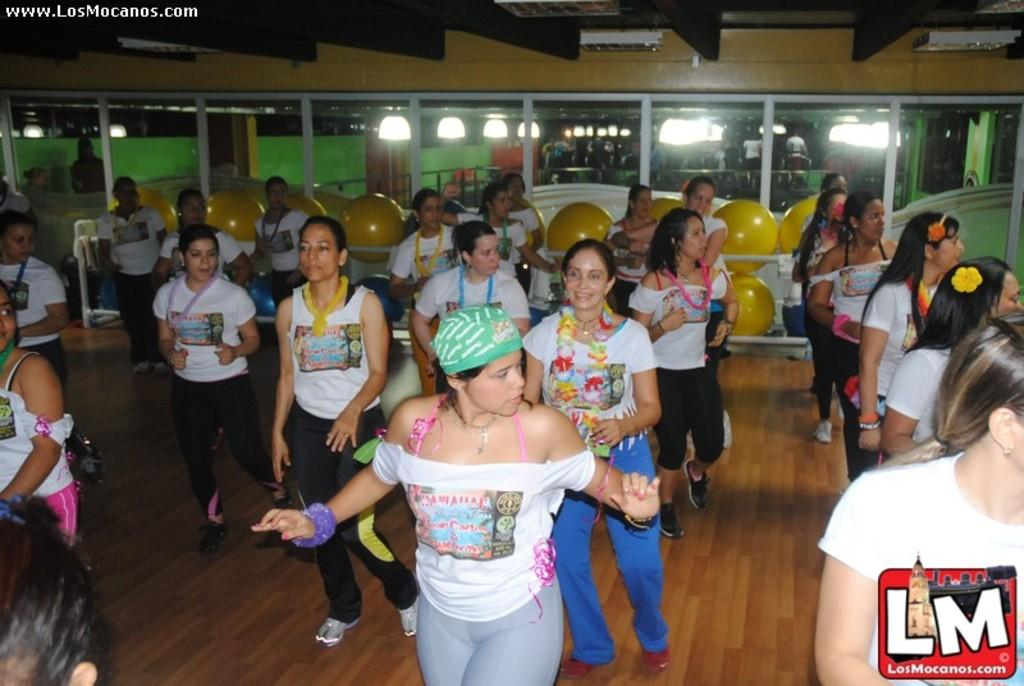What are the people in the image doing? The people in the image are standing on the surface. What objects can be seen in the image that reflect light? There are mirrors in the image that reflect light. What is on the roof in the image? There are light arrangements on the roof in the image. What type of objects are present in the image that are round? There are balls in the image. Can you tell me how deep the river is in the image? There is no river present in the image, so it is not possible to determine its depth. 